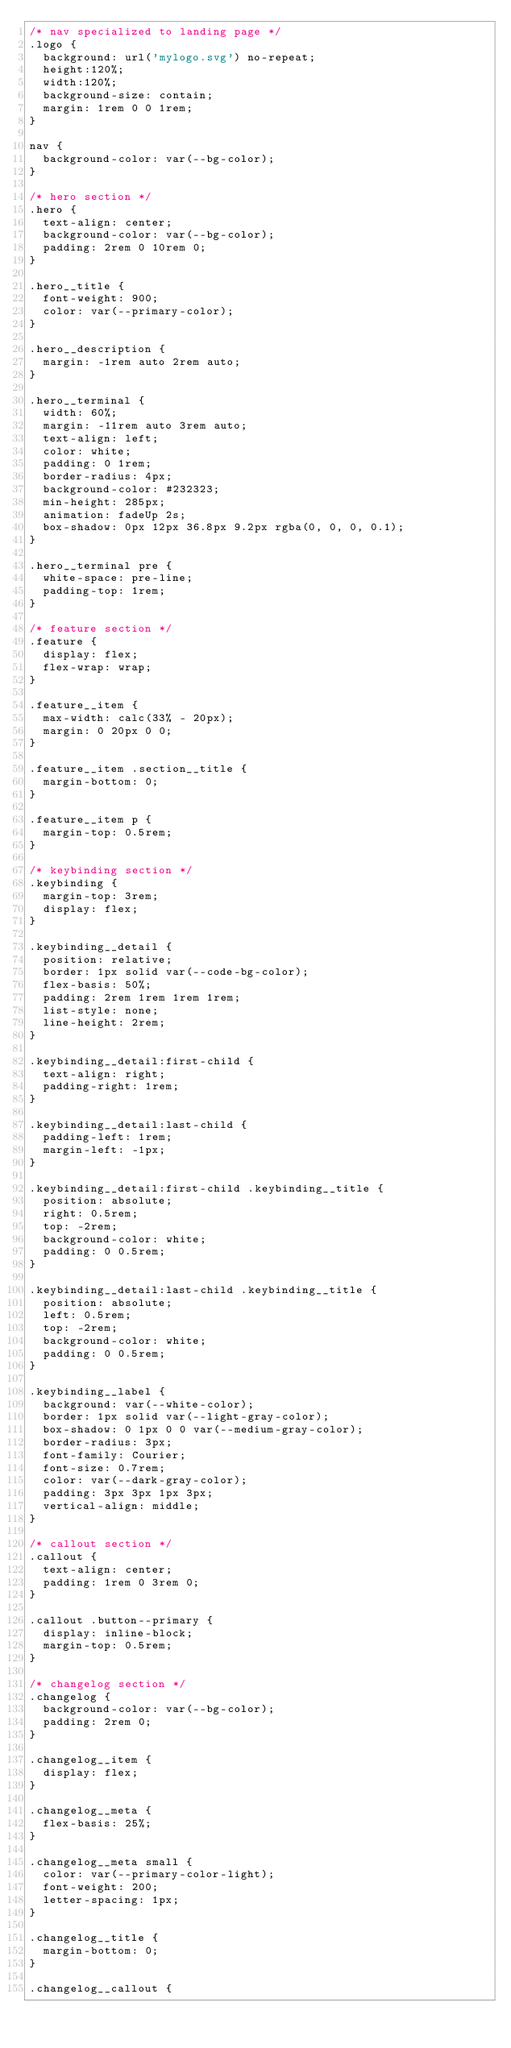Convert code to text. <code><loc_0><loc_0><loc_500><loc_500><_CSS_>/* nav specialized to landing page */
.logo {
  background: url('mylogo.svg') no-repeat;
  height:120%;
  width:120%;
  background-size: contain;
  margin: 1rem 0 0 1rem;
}

nav {
  background-color: var(--bg-color);
}

/* hero section */
.hero {
  text-align: center;
  background-color: var(--bg-color);
  padding: 2rem 0 10rem 0;
}

.hero__title {
  font-weight: 900;
  color: var(--primary-color);
}

.hero__description {
  margin: -1rem auto 2rem auto;
}

.hero__terminal {
  width: 60%;
  margin: -11rem auto 3rem auto;
  text-align: left;
  color: white;
  padding: 0 1rem;
  border-radius: 4px;
  background-color: #232323;
  min-height: 285px;
  animation: fadeUp 2s;
  box-shadow: 0px 12px 36.8px 9.2px rgba(0, 0, 0, 0.1);
}

.hero__terminal pre {
  white-space: pre-line;
  padding-top: 1rem;
}

/* feature section */
.feature {
  display: flex;
  flex-wrap: wrap;
}

.feature__item {
  max-width: calc(33% - 20px);
  margin: 0 20px 0 0;
}

.feature__item .section__title {
  margin-bottom: 0;
}

.feature__item p {
  margin-top: 0.5rem;
}

/* keybinding section */
.keybinding {
  margin-top: 3rem;
  display: flex;
}

.keybinding__detail {
  position: relative;
  border: 1px solid var(--code-bg-color);
  flex-basis: 50%;
  padding: 2rem 1rem 1rem 1rem;
  list-style: none;
  line-height: 2rem;
}

.keybinding__detail:first-child {
  text-align: right;
  padding-right: 1rem;
}

.keybinding__detail:last-child {
  padding-left: 1rem;
  margin-left: -1px;
}

.keybinding__detail:first-child .keybinding__title {
  position: absolute;
  right: 0.5rem;
  top: -2rem;
  background-color: white;
  padding: 0 0.5rem;
}

.keybinding__detail:last-child .keybinding__title {
  position: absolute;
  left: 0.5rem;
  top: -2rem;
  background-color: white;
  padding: 0 0.5rem;
}

.keybinding__label {
  background: var(--white-color);
  border: 1px solid var(--light-gray-color);
  box-shadow: 0 1px 0 0 var(--medium-gray-color);
  border-radius: 3px;
  font-family: Courier;
  font-size: 0.7rem;
  color: var(--dark-gray-color);
  padding: 3px 3px 1px 3px;
  vertical-align: middle;
}

/* callout section */
.callout {
  text-align: center;
  padding: 1rem 0 3rem 0;
}

.callout .button--primary {
  display: inline-block;
  margin-top: 0.5rem;
}

/* changelog section */
.changelog {
  background-color: var(--bg-color);
  padding: 2rem 0;
}

.changelog__item {
  display: flex;
}

.changelog__meta {
  flex-basis: 25%;
}

.changelog__meta small {
  color: var(--primary-color-light);
  font-weight: 200;
  letter-spacing: 1px;
}

.changelog__title {
  margin-bottom: 0;
}

.changelog__callout {</code> 